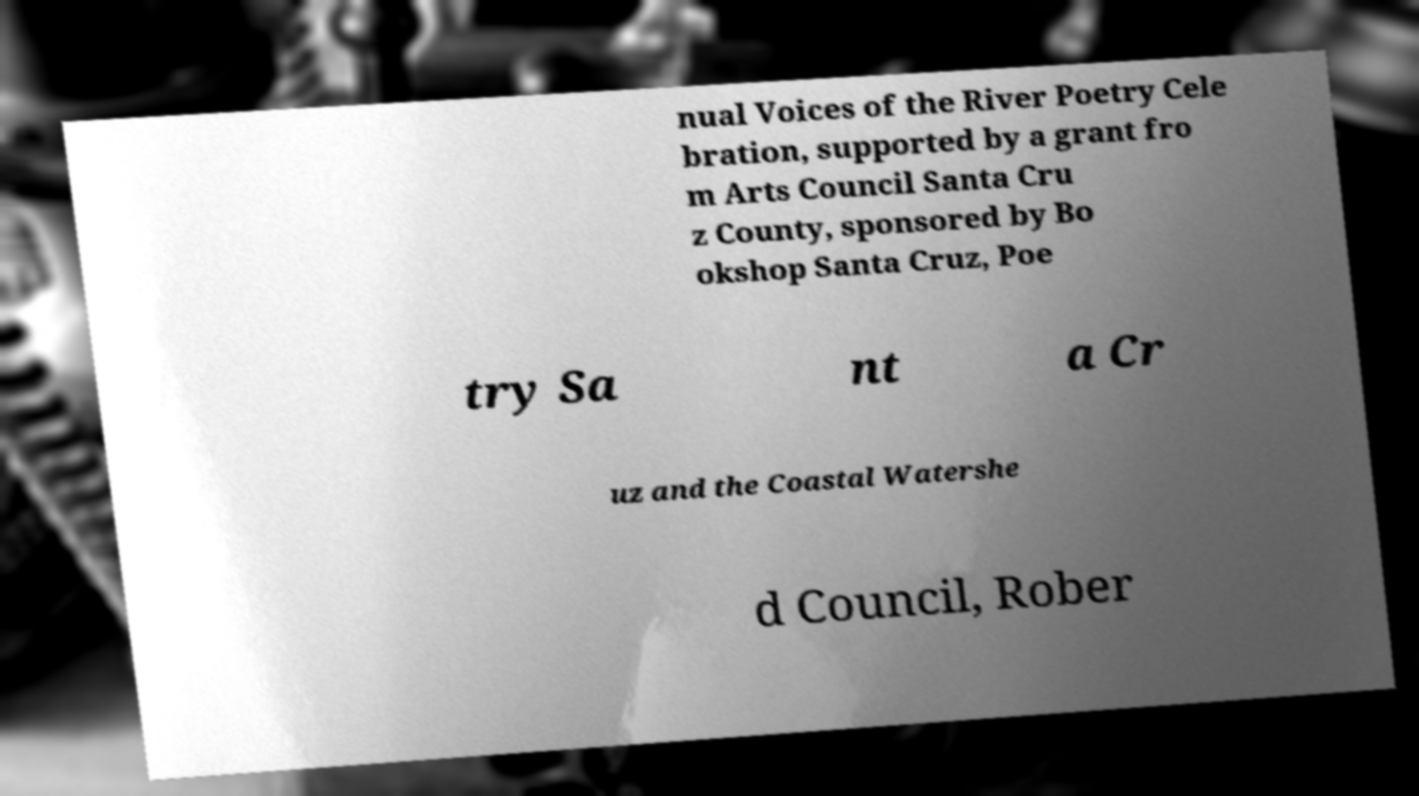Please read and relay the text visible in this image. What does it say? nual Voices of the River Poetry Cele bration, supported by a grant fro m Arts Council Santa Cru z County, sponsored by Bo okshop Santa Cruz, Poe try Sa nt a Cr uz and the Coastal Watershe d Council, Rober 